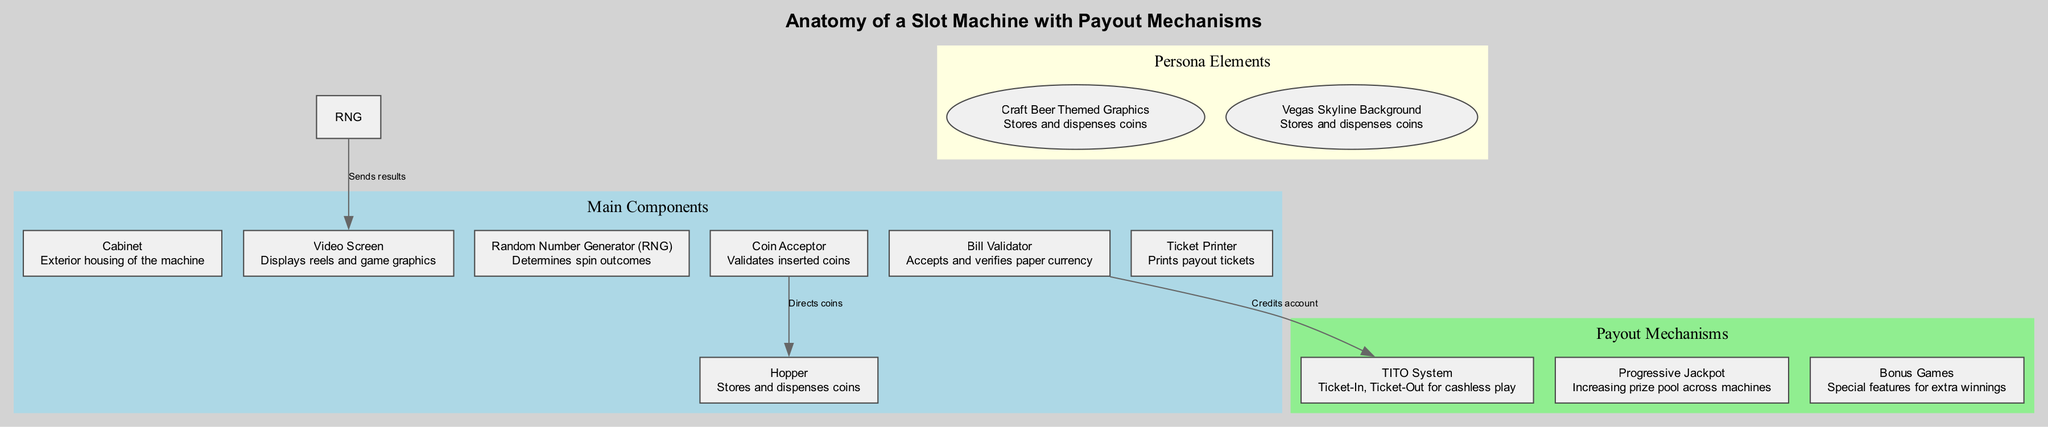What is the title of the diagram? The title is clearly stated at the top of the diagram, labeled as "Anatomy of a Slot Machine with Payout Mechanisms."
Answer: Anatomy of a Slot Machine with Payout Mechanisms How many main components are shown in the diagram? By counting the nodes in the "Main Components" subgraph, there are 7 distinct nodes listed.
Answer: 7 What mechanism increases the prize pool across machines? The diagram indicates that "Progressive Jackpot" is the term used to describe the growing prize pool mechanism.
Answer: Progressive Jackpot Which component validates inserted coins? The "Coin Acceptor" is explicitly described as the part of the machine that validates the coins being inserted.
Answer: Coin Acceptor What does the Random Number Generator determine? The Random Number Generator (RNG) is responsible for determining the outcomes of each spin according to the diagram.
Answer: Spin outcomes How does the Bill Validator connect to the payout system? The Bill Validator sends information to the TITO System, which credits the account when a bill is validated; this is shown in the connection arrow labeled "Credits account."
Answer: Credits account What are the two additional elements included that reflect local culture? The persona elements include "Craft Beer Themed Graphics" and "Vegas Skyline Background," both of which are unique to the local context.
Answer: Craft Beer Themed Graphics and Vegas Skyline Background What role does the Hopper play in the machine system? The Hopper is designated in the diagram as the component that stores and dispenses coins, linking to the Coin Acceptor.
Answer: Stores and dispenses coins What type of system is associated with cashless play? "TITO System," or Ticket-In, Ticket-Out, is described in the diagram as the mechanism that facilitates cashless transactions within the slot machine.
Answer: TITO System 